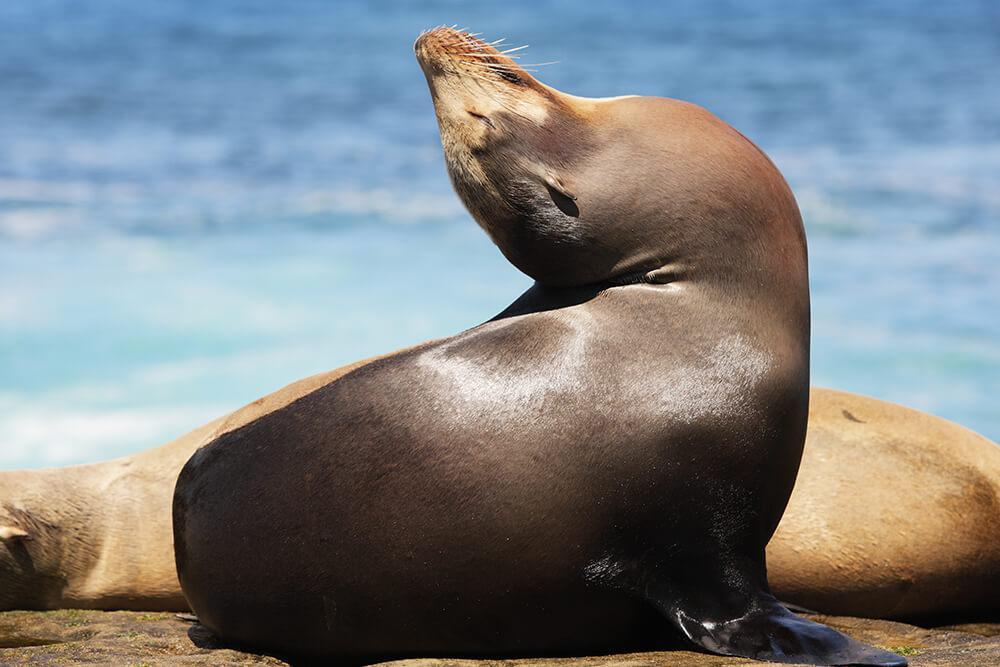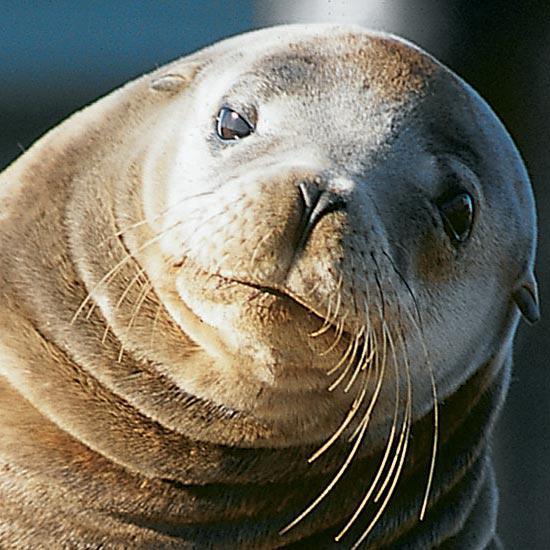The first image is the image on the left, the second image is the image on the right. For the images displayed, is the sentence "There is water in the image on the left." factually correct? Answer yes or no. Yes. The first image is the image on the left, the second image is the image on the right. Examine the images to the left and right. Is the description "An image shows only one seal in close-up, with its head cocked at an angle to the right." accurate? Answer yes or no. Yes. 